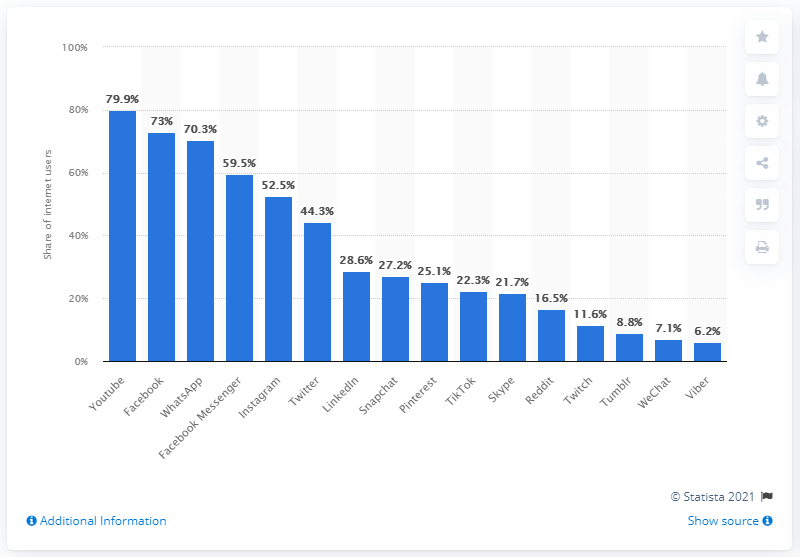Outline some significant characteristics in this image. In the UK, the rate of Facebook use among internet users was 73%. 